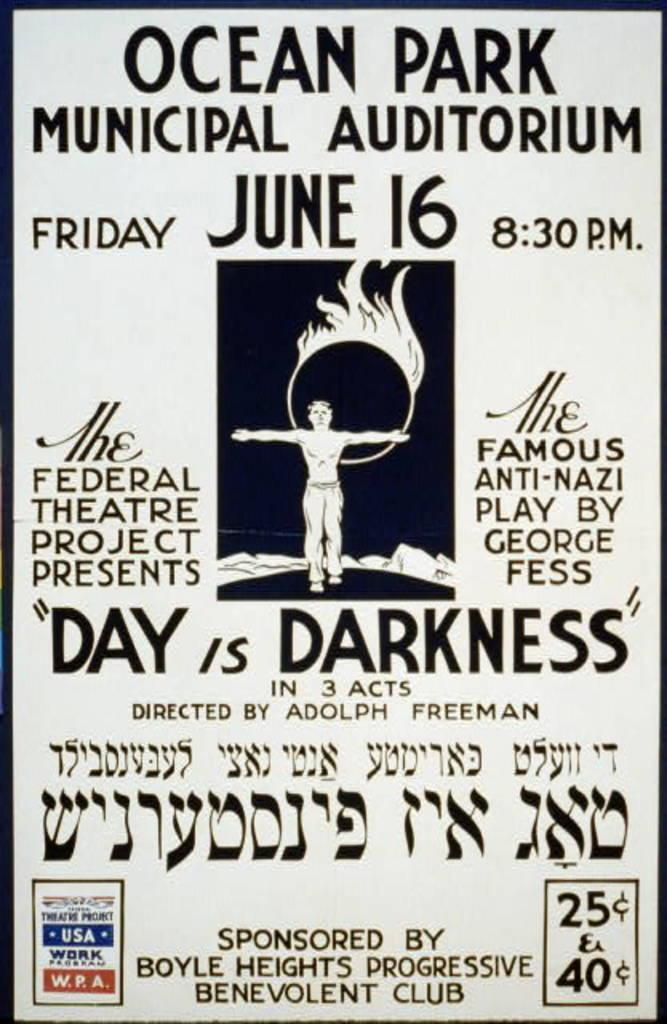<image>
Render a clear and concise summary of the photo. An advertisement for Ocean park Municipal Auditorium for a theater act on June 16 